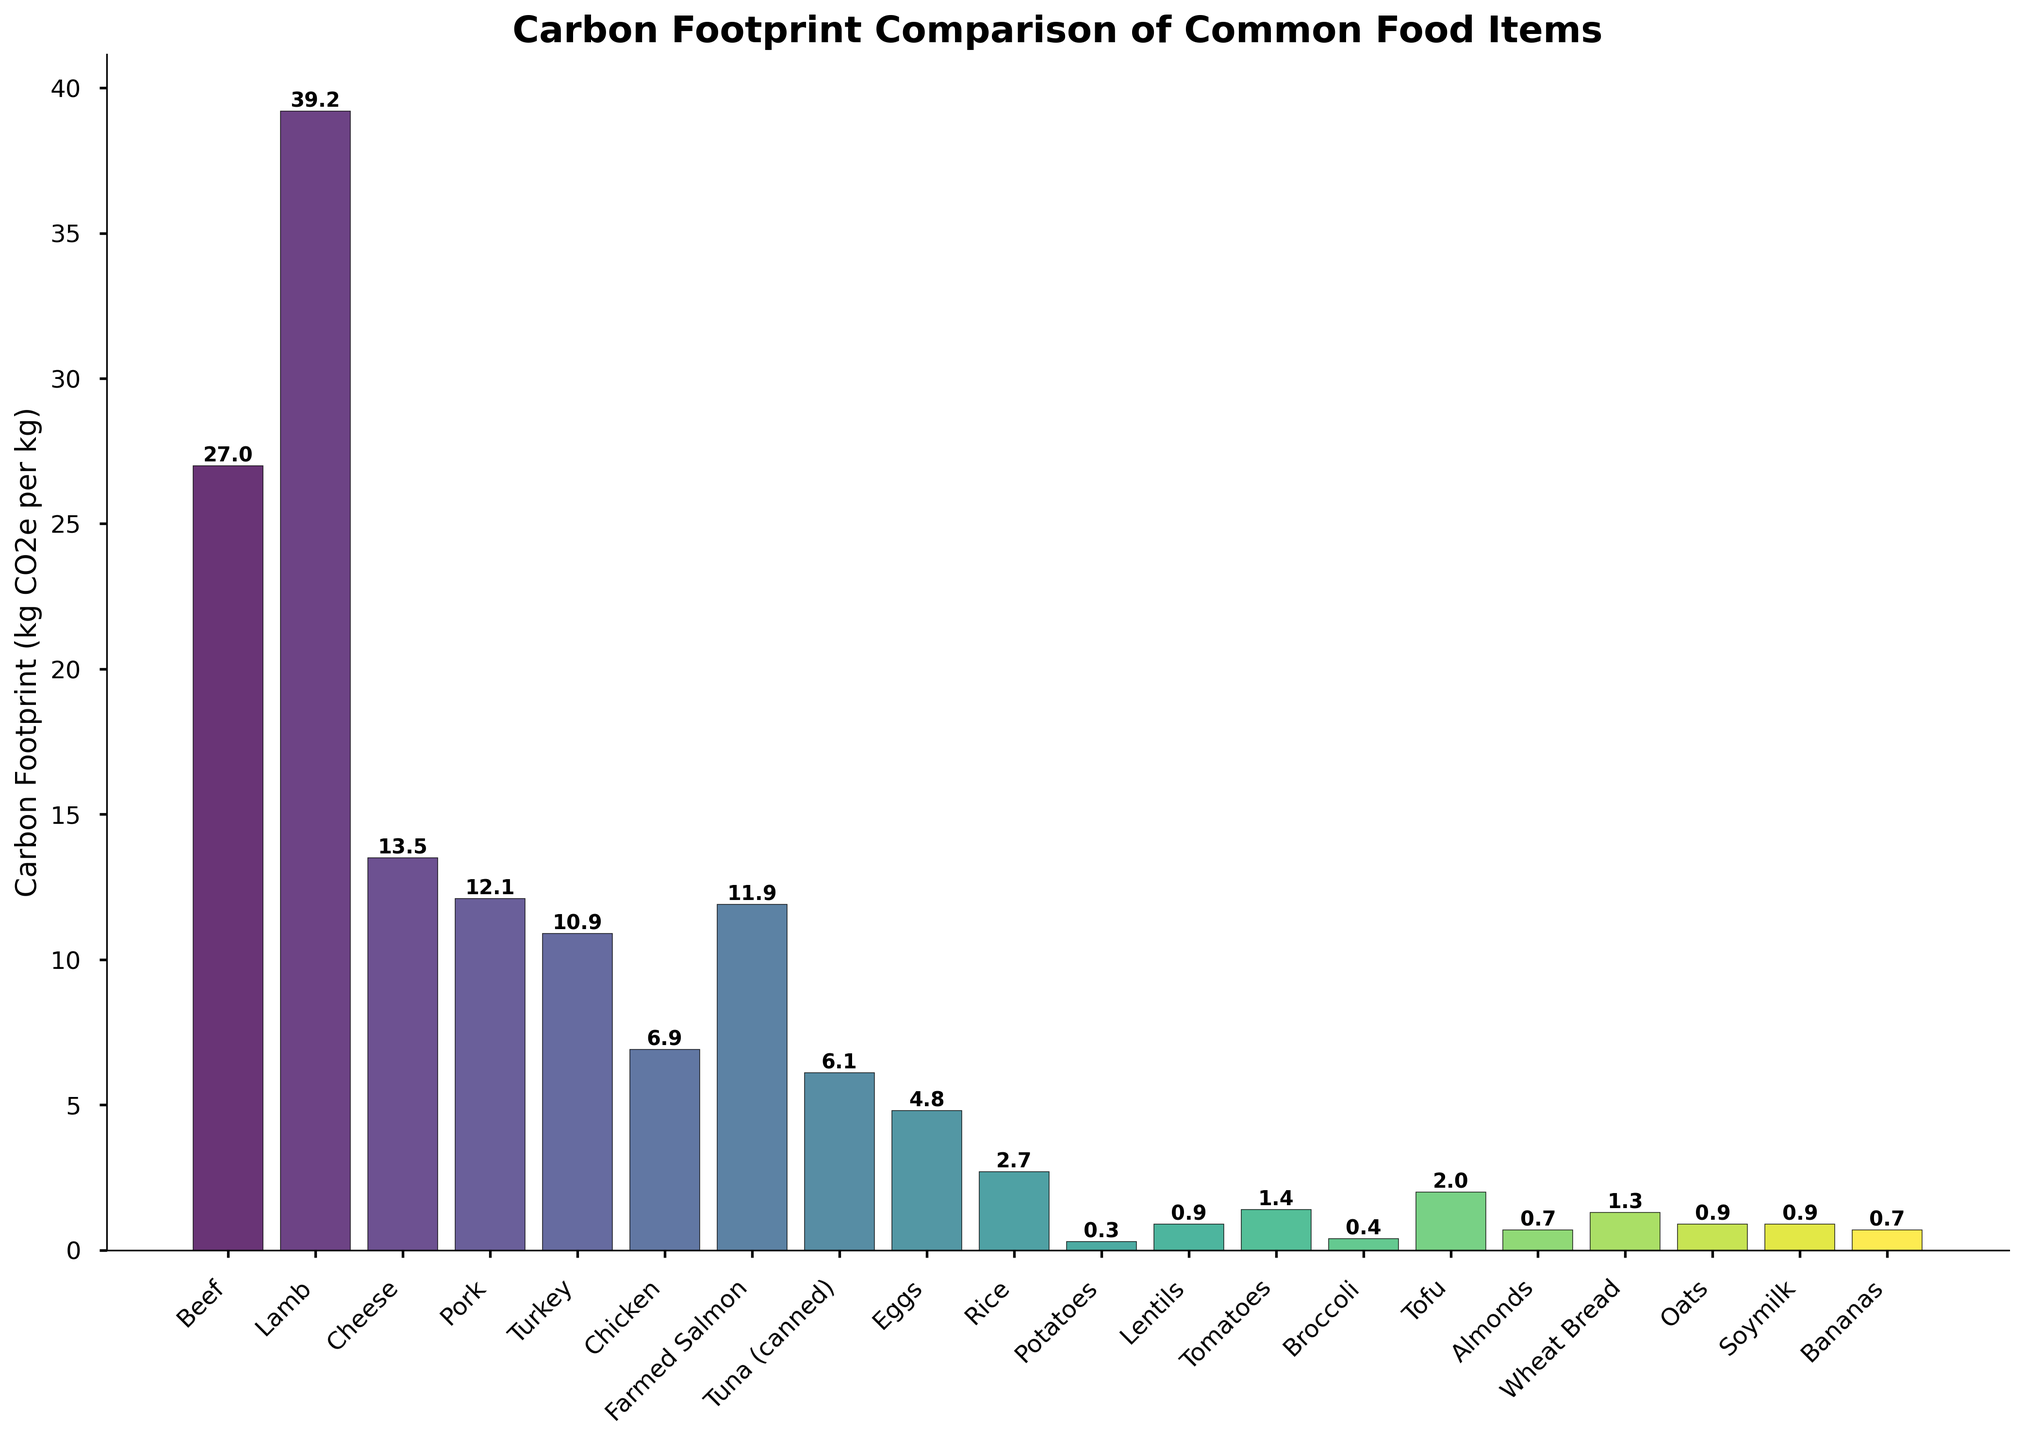Which food item has the highest carbon footprint? The bar with the highest height indicates the food item with the highest carbon footprint. In this case, Lamb shows the tallest bar at 39.2 kg CO2e per kg.
Answer: Lamb Which food items have a carbon footprint less than 5 kg CO2e per kg? Identify bars with heights below the 5 kg CO2e per kg mark. The food items that have bars shorter than this threshold are Eggs, Rice, Potatoes, Lentils, Tomatoes, Broccoli, Tofu, Almonds, Wheat Bread, Oats, Soymilk, and Bananas.
Answer: Eggs, Rice, Potatoes, Lentils, Tomatoes, Broccoli, Tofu, Almonds, Wheat Bread, Oats, Soymilk, Bananas How much higher is the carbon footprint of Beef compared to Chicken? Find the heights of the bars for Beef and Chicken. Beef has a carbon footprint of 27.0 kg CO2e per kg, while Chicken has 6.9 kg CO2e per kg. Subtract the value for Chicken from Beef: 27.0 - 6.9 = 20.1.
Answer: 20.1 kg CO2e per kg What is the average carbon footprint of all food items shown? Sum the carbon footprints of all food items and divide by the number of items. Total sum = 27.0 + 39.2 + 13.5 + 12.1 + 10.9 + 6.9 + 11.9 + 6.1 + 4.8 + 2.7 + 0.3 + 0.9 + 1.4 + 0.4 + 2.0 + 0.7 + 1.3 + 0.9 + 0.9 + 0.7 = 144.6. Number of items = 20. The average is 144.6 / 20 = 7.23 kg CO2e per kg.
Answer: 7.23 kg CO2e per kg Which has a higher carbon footprint: Farmed Salmon or Pork? Compare the heights of the bars for Farmed Salmon (11.9 kg CO2e per kg) and Pork (12.1 kg CO2e per kg). Pork is slightly higher than Farmed Salmon.
Answer: Pork What is the total carbon footprint for all vegetables (Tomatoes, Potatoes, Broccoli) combined? Add the carbon footprints of Tomatoes, Potatoes, and Broccoli. Tomatoes = 1.4, Potatoes = 0.3, Broccoli = 0.4. So, total = 1.4 + 0.3 + 0.4 = 2.1 kg CO2e per kg.
Answer: 2.1 kg CO2e per kg Rank the top three food items with the highest carbon footprint. Visually identify the three tallest bars. The tallest bars correspond to the following food items: Lamb, Beef, Cheese.
Answer: Lamb, Beef, Cheese How does the carbon footprint of Eggs compare to Tofu? Compare the heights of the bars for Eggs (4.8 kg CO2e per kg) and Tofu (2.0 kg CO2e per kg). Eggs have a higher carbon footprint than Tofu.
Answer: Eggs Which food item has a carbon footprint closest to 1 kg CO2e per kg? Look for the bar closest to the 1 kg CO2e per kg mark. The food items close to this value are Lentils (0.9), Tomatoes (1.4), and Wheat Bread (1.3). Lentils and Wheat Bread, being 0.9, are the closest.
Answer: Lentils, Wheat Bread What is the difference between the carbon footprints of Tuna (canned) and Rice? Identify the bars for Tuna (canned) and Rice. The values are Tuna (6.1 kg CO2e per kg) and Rice (2.7 kg CO2e per kg). The difference is 6.1 - 2.7 = 3.4 kg CO2e per kg.
Answer: 3.4 kg CO2e per kg 